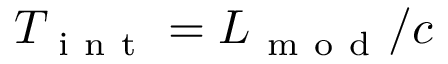Convert formula to latex. <formula><loc_0><loc_0><loc_500><loc_500>T _ { i n t } = L _ { m o d } / c</formula> 